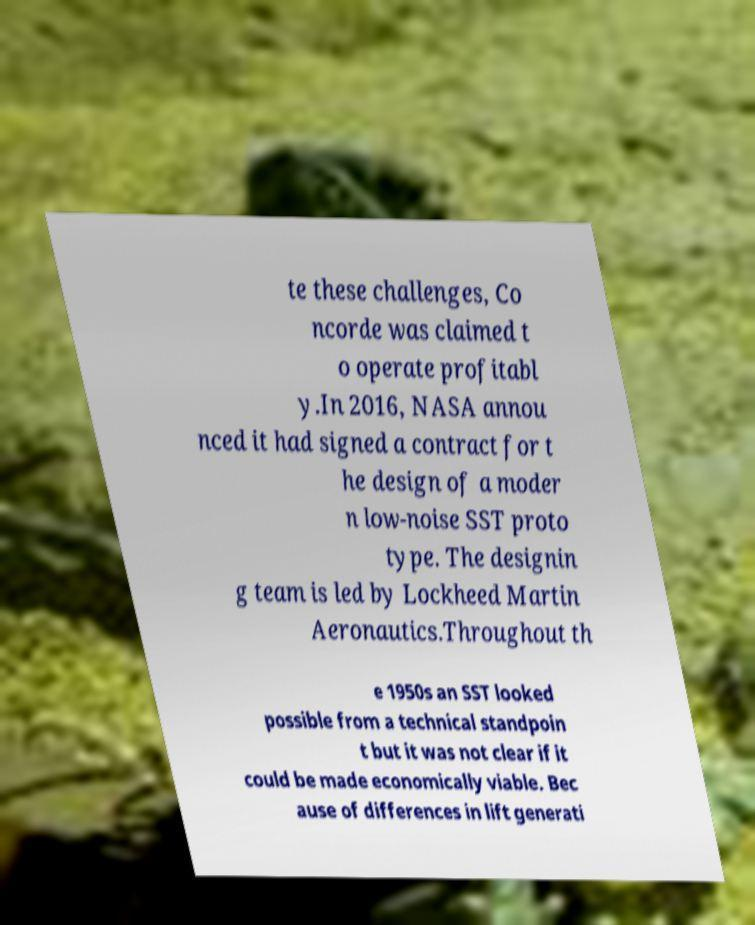Please read and relay the text visible in this image. What does it say? te these challenges, Co ncorde was claimed t o operate profitabl y.In 2016, NASA annou nced it had signed a contract for t he design of a moder n low-noise SST proto type. The designin g team is led by Lockheed Martin Aeronautics.Throughout th e 1950s an SST looked possible from a technical standpoin t but it was not clear if it could be made economically viable. Bec ause of differences in lift generati 